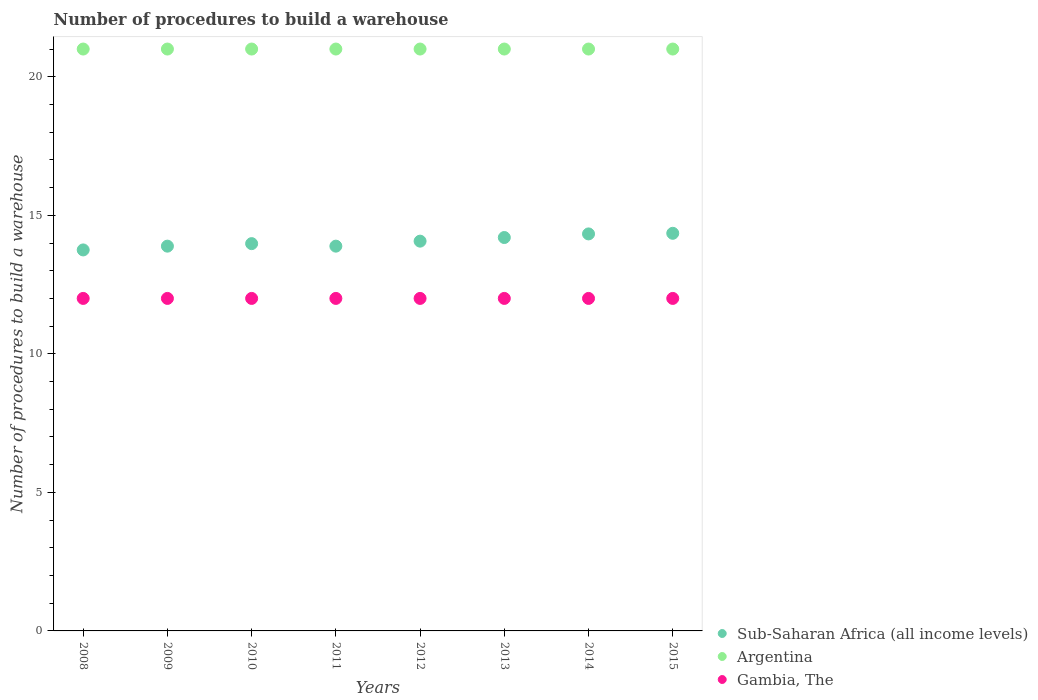How many different coloured dotlines are there?
Give a very brief answer. 3. Is the number of dotlines equal to the number of legend labels?
Make the answer very short. Yes. What is the number of procedures to build a warehouse in in Sub-Saharan Africa (all income levels) in 2011?
Offer a very short reply. 13.89. Across all years, what is the maximum number of procedures to build a warehouse in in Argentina?
Provide a succinct answer. 21. Across all years, what is the minimum number of procedures to build a warehouse in in Gambia, The?
Ensure brevity in your answer.  12. In which year was the number of procedures to build a warehouse in in Gambia, The maximum?
Your answer should be compact. 2008. In which year was the number of procedures to build a warehouse in in Gambia, The minimum?
Offer a terse response. 2008. What is the total number of procedures to build a warehouse in in Gambia, The in the graph?
Your answer should be very brief. 96. What is the difference between the number of procedures to build a warehouse in in Argentina in 2013 and that in 2015?
Give a very brief answer. 0. What is the difference between the number of procedures to build a warehouse in in Sub-Saharan Africa (all income levels) in 2012 and the number of procedures to build a warehouse in in Argentina in 2009?
Offer a very short reply. -6.93. What is the average number of procedures to build a warehouse in in Sub-Saharan Africa (all income levels) per year?
Offer a very short reply. 14.06. In the year 2013, what is the difference between the number of procedures to build a warehouse in in Gambia, The and number of procedures to build a warehouse in in Argentina?
Your answer should be compact. -9. In how many years, is the number of procedures to build a warehouse in in Argentina greater than 10?
Provide a short and direct response. 8. What is the ratio of the number of procedures to build a warehouse in in Gambia, The in 2011 to that in 2015?
Your answer should be very brief. 1. Is the number of procedures to build a warehouse in in Argentina in 2008 less than that in 2013?
Offer a very short reply. No. What is the difference between the highest and the second highest number of procedures to build a warehouse in in Sub-Saharan Africa (all income levels)?
Offer a very short reply. 0.02. What is the difference between the highest and the lowest number of procedures to build a warehouse in in Sub-Saharan Africa (all income levels)?
Ensure brevity in your answer.  0.6. Is the sum of the number of procedures to build a warehouse in in Argentina in 2011 and 2012 greater than the maximum number of procedures to build a warehouse in in Sub-Saharan Africa (all income levels) across all years?
Your answer should be compact. Yes. Is it the case that in every year, the sum of the number of procedures to build a warehouse in in Argentina and number of procedures to build a warehouse in in Sub-Saharan Africa (all income levels)  is greater than the number of procedures to build a warehouse in in Gambia, The?
Give a very brief answer. Yes. Is the number of procedures to build a warehouse in in Gambia, The strictly greater than the number of procedures to build a warehouse in in Sub-Saharan Africa (all income levels) over the years?
Ensure brevity in your answer.  No. Is the number of procedures to build a warehouse in in Argentina strictly less than the number of procedures to build a warehouse in in Gambia, The over the years?
Ensure brevity in your answer.  No. Are the values on the major ticks of Y-axis written in scientific E-notation?
Provide a short and direct response. No. Does the graph contain grids?
Your answer should be compact. No. Where does the legend appear in the graph?
Your answer should be very brief. Bottom right. How many legend labels are there?
Your response must be concise. 3. How are the legend labels stacked?
Make the answer very short. Vertical. What is the title of the graph?
Give a very brief answer. Number of procedures to build a warehouse. What is the label or title of the X-axis?
Make the answer very short. Years. What is the label or title of the Y-axis?
Provide a short and direct response. Number of procedures to build a warehouse. What is the Number of procedures to build a warehouse of Sub-Saharan Africa (all income levels) in 2008?
Give a very brief answer. 13.75. What is the Number of procedures to build a warehouse in Argentina in 2008?
Your answer should be very brief. 21. What is the Number of procedures to build a warehouse of Gambia, The in 2008?
Your response must be concise. 12. What is the Number of procedures to build a warehouse of Sub-Saharan Africa (all income levels) in 2009?
Provide a short and direct response. 13.89. What is the Number of procedures to build a warehouse in Gambia, The in 2009?
Your answer should be very brief. 12. What is the Number of procedures to build a warehouse in Sub-Saharan Africa (all income levels) in 2010?
Offer a very short reply. 13.98. What is the Number of procedures to build a warehouse of Argentina in 2010?
Ensure brevity in your answer.  21. What is the Number of procedures to build a warehouse of Sub-Saharan Africa (all income levels) in 2011?
Your answer should be very brief. 13.89. What is the Number of procedures to build a warehouse of Argentina in 2011?
Provide a short and direct response. 21. What is the Number of procedures to build a warehouse of Gambia, The in 2011?
Offer a terse response. 12. What is the Number of procedures to build a warehouse in Sub-Saharan Africa (all income levels) in 2012?
Your answer should be compact. 14.07. What is the Number of procedures to build a warehouse in Sub-Saharan Africa (all income levels) in 2013?
Offer a terse response. 14.2. What is the Number of procedures to build a warehouse of Sub-Saharan Africa (all income levels) in 2014?
Ensure brevity in your answer.  14.33. What is the Number of procedures to build a warehouse of Sub-Saharan Africa (all income levels) in 2015?
Your response must be concise. 14.35. Across all years, what is the maximum Number of procedures to build a warehouse in Sub-Saharan Africa (all income levels)?
Offer a terse response. 14.35. Across all years, what is the maximum Number of procedures to build a warehouse of Argentina?
Give a very brief answer. 21. Across all years, what is the minimum Number of procedures to build a warehouse in Sub-Saharan Africa (all income levels)?
Ensure brevity in your answer.  13.75. What is the total Number of procedures to build a warehouse of Sub-Saharan Africa (all income levels) in the graph?
Your response must be concise. 112.44. What is the total Number of procedures to build a warehouse in Argentina in the graph?
Your answer should be very brief. 168. What is the total Number of procedures to build a warehouse in Gambia, The in the graph?
Your answer should be very brief. 96. What is the difference between the Number of procedures to build a warehouse of Sub-Saharan Africa (all income levels) in 2008 and that in 2009?
Your response must be concise. -0.14. What is the difference between the Number of procedures to build a warehouse in Argentina in 2008 and that in 2009?
Give a very brief answer. 0. What is the difference between the Number of procedures to build a warehouse of Sub-Saharan Africa (all income levels) in 2008 and that in 2010?
Make the answer very short. -0.23. What is the difference between the Number of procedures to build a warehouse of Argentina in 2008 and that in 2010?
Ensure brevity in your answer.  0. What is the difference between the Number of procedures to build a warehouse of Gambia, The in 2008 and that in 2010?
Keep it short and to the point. 0. What is the difference between the Number of procedures to build a warehouse in Sub-Saharan Africa (all income levels) in 2008 and that in 2011?
Your answer should be compact. -0.14. What is the difference between the Number of procedures to build a warehouse of Sub-Saharan Africa (all income levels) in 2008 and that in 2012?
Provide a short and direct response. -0.32. What is the difference between the Number of procedures to build a warehouse of Argentina in 2008 and that in 2012?
Ensure brevity in your answer.  0. What is the difference between the Number of procedures to build a warehouse in Sub-Saharan Africa (all income levels) in 2008 and that in 2013?
Your answer should be compact. -0.45. What is the difference between the Number of procedures to build a warehouse in Argentina in 2008 and that in 2013?
Provide a short and direct response. 0. What is the difference between the Number of procedures to build a warehouse in Gambia, The in 2008 and that in 2013?
Your response must be concise. 0. What is the difference between the Number of procedures to build a warehouse in Sub-Saharan Africa (all income levels) in 2008 and that in 2014?
Your answer should be very brief. -0.58. What is the difference between the Number of procedures to build a warehouse of Sub-Saharan Africa (all income levels) in 2009 and that in 2010?
Your answer should be compact. -0.09. What is the difference between the Number of procedures to build a warehouse in Argentina in 2009 and that in 2010?
Give a very brief answer. 0. What is the difference between the Number of procedures to build a warehouse in Sub-Saharan Africa (all income levels) in 2009 and that in 2012?
Give a very brief answer. -0.18. What is the difference between the Number of procedures to build a warehouse in Gambia, The in 2009 and that in 2012?
Make the answer very short. 0. What is the difference between the Number of procedures to build a warehouse in Sub-Saharan Africa (all income levels) in 2009 and that in 2013?
Your response must be concise. -0.31. What is the difference between the Number of procedures to build a warehouse in Gambia, The in 2009 and that in 2013?
Give a very brief answer. 0. What is the difference between the Number of procedures to build a warehouse of Sub-Saharan Africa (all income levels) in 2009 and that in 2014?
Keep it short and to the point. -0.44. What is the difference between the Number of procedures to build a warehouse of Argentina in 2009 and that in 2014?
Keep it short and to the point. 0. What is the difference between the Number of procedures to build a warehouse of Sub-Saharan Africa (all income levels) in 2009 and that in 2015?
Ensure brevity in your answer.  -0.46. What is the difference between the Number of procedures to build a warehouse of Sub-Saharan Africa (all income levels) in 2010 and that in 2011?
Your response must be concise. 0.09. What is the difference between the Number of procedures to build a warehouse in Gambia, The in 2010 and that in 2011?
Your answer should be compact. 0. What is the difference between the Number of procedures to build a warehouse of Sub-Saharan Africa (all income levels) in 2010 and that in 2012?
Offer a very short reply. -0.09. What is the difference between the Number of procedures to build a warehouse of Argentina in 2010 and that in 2012?
Your response must be concise. 0. What is the difference between the Number of procedures to build a warehouse in Gambia, The in 2010 and that in 2012?
Offer a very short reply. 0. What is the difference between the Number of procedures to build a warehouse of Sub-Saharan Africa (all income levels) in 2010 and that in 2013?
Make the answer very short. -0.22. What is the difference between the Number of procedures to build a warehouse in Argentina in 2010 and that in 2013?
Ensure brevity in your answer.  0. What is the difference between the Number of procedures to build a warehouse in Sub-Saharan Africa (all income levels) in 2010 and that in 2014?
Your response must be concise. -0.35. What is the difference between the Number of procedures to build a warehouse in Argentina in 2010 and that in 2014?
Offer a very short reply. 0. What is the difference between the Number of procedures to build a warehouse of Gambia, The in 2010 and that in 2014?
Provide a short and direct response. 0. What is the difference between the Number of procedures to build a warehouse of Sub-Saharan Africa (all income levels) in 2010 and that in 2015?
Give a very brief answer. -0.37. What is the difference between the Number of procedures to build a warehouse of Gambia, The in 2010 and that in 2015?
Your answer should be compact. 0. What is the difference between the Number of procedures to build a warehouse in Sub-Saharan Africa (all income levels) in 2011 and that in 2012?
Give a very brief answer. -0.18. What is the difference between the Number of procedures to build a warehouse in Sub-Saharan Africa (all income levels) in 2011 and that in 2013?
Provide a succinct answer. -0.31. What is the difference between the Number of procedures to build a warehouse in Argentina in 2011 and that in 2013?
Ensure brevity in your answer.  0. What is the difference between the Number of procedures to build a warehouse of Sub-Saharan Africa (all income levels) in 2011 and that in 2014?
Provide a succinct answer. -0.44. What is the difference between the Number of procedures to build a warehouse of Sub-Saharan Africa (all income levels) in 2011 and that in 2015?
Provide a short and direct response. -0.46. What is the difference between the Number of procedures to build a warehouse of Argentina in 2011 and that in 2015?
Provide a short and direct response. 0. What is the difference between the Number of procedures to build a warehouse of Gambia, The in 2011 and that in 2015?
Ensure brevity in your answer.  0. What is the difference between the Number of procedures to build a warehouse of Sub-Saharan Africa (all income levels) in 2012 and that in 2013?
Provide a short and direct response. -0.13. What is the difference between the Number of procedures to build a warehouse in Argentina in 2012 and that in 2013?
Provide a succinct answer. 0. What is the difference between the Number of procedures to build a warehouse in Gambia, The in 2012 and that in 2013?
Your response must be concise. 0. What is the difference between the Number of procedures to build a warehouse in Sub-Saharan Africa (all income levels) in 2012 and that in 2014?
Provide a succinct answer. -0.26. What is the difference between the Number of procedures to build a warehouse in Gambia, The in 2012 and that in 2014?
Give a very brief answer. 0. What is the difference between the Number of procedures to build a warehouse in Sub-Saharan Africa (all income levels) in 2012 and that in 2015?
Your response must be concise. -0.28. What is the difference between the Number of procedures to build a warehouse in Gambia, The in 2012 and that in 2015?
Ensure brevity in your answer.  0. What is the difference between the Number of procedures to build a warehouse in Sub-Saharan Africa (all income levels) in 2013 and that in 2014?
Keep it short and to the point. -0.13. What is the difference between the Number of procedures to build a warehouse of Argentina in 2013 and that in 2014?
Provide a short and direct response. 0. What is the difference between the Number of procedures to build a warehouse of Gambia, The in 2013 and that in 2014?
Provide a succinct answer. 0. What is the difference between the Number of procedures to build a warehouse in Sub-Saharan Africa (all income levels) in 2013 and that in 2015?
Provide a succinct answer. -0.15. What is the difference between the Number of procedures to build a warehouse in Sub-Saharan Africa (all income levels) in 2014 and that in 2015?
Give a very brief answer. -0.02. What is the difference between the Number of procedures to build a warehouse of Argentina in 2014 and that in 2015?
Offer a terse response. 0. What is the difference between the Number of procedures to build a warehouse in Sub-Saharan Africa (all income levels) in 2008 and the Number of procedures to build a warehouse in Argentina in 2009?
Your answer should be compact. -7.25. What is the difference between the Number of procedures to build a warehouse in Sub-Saharan Africa (all income levels) in 2008 and the Number of procedures to build a warehouse in Gambia, The in 2009?
Your answer should be very brief. 1.75. What is the difference between the Number of procedures to build a warehouse in Sub-Saharan Africa (all income levels) in 2008 and the Number of procedures to build a warehouse in Argentina in 2010?
Provide a short and direct response. -7.25. What is the difference between the Number of procedures to build a warehouse of Argentina in 2008 and the Number of procedures to build a warehouse of Gambia, The in 2010?
Give a very brief answer. 9. What is the difference between the Number of procedures to build a warehouse of Sub-Saharan Africa (all income levels) in 2008 and the Number of procedures to build a warehouse of Argentina in 2011?
Provide a short and direct response. -7.25. What is the difference between the Number of procedures to build a warehouse in Sub-Saharan Africa (all income levels) in 2008 and the Number of procedures to build a warehouse in Gambia, The in 2011?
Offer a terse response. 1.75. What is the difference between the Number of procedures to build a warehouse of Argentina in 2008 and the Number of procedures to build a warehouse of Gambia, The in 2011?
Ensure brevity in your answer.  9. What is the difference between the Number of procedures to build a warehouse in Sub-Saharan Africa (all income levels) in 2008 and the Number of procedures to build a warehouse in Argentina in 2012?
Give a very brief answer. -7.25. What is the difference between the Number of procedures to build a warehouse of Sub-Saharan Africa (all income levels) in 2008 and the Number of procedures to build a warehouse of Argentina in 2013?
Give a very brief answer. -7.25. What is the difference between the Number of procedures to build a warehouse of Sub-Saharan Africa (all income levels) in 2008 and the Number of procedures to build a warehouse of Gambia, The in 2013?
Your answer should be very brief. 1.75. What is the difference between the Number of procedures to build a warehouse in Sub-Saharan Africa (all income levels) in 2008 and the Number of procedures to build a warehouse in Argentina in 2014?
Your answer should be compact. -7.25. What is the difference between the Number of procedures to build a warehouse of Sub-Saharan Africa (all income levels) in 2008 and the Number of procedures to build a warehouse of Gambia, The in 2014?
Your answer should be compact. 1.75. What is the difference between the Number of procedures to build a warehouse in Sub-Saharan Africa (all income levels) in 2008 and the Number of procedures to build a warehouse in Argentina in 2015?
Give a very brief answer. -7.25. What is the difference between the Number of procedures to build a warehouse in Sub-Saharan Africa (all income levels) in 2008 and the Number of procedures to build a warehouse in Gambia, The in 2015?
Offer a terse response. 1.75. What is the difference between the Number of procedures to build a warehouse of Argentina in 2008 and the Number of procedures to build a warehouse of Gambia, The in 2015?
Offer a very short reply. 9. What is the difference between the Number of procedures to build a warehouse in Sub-Saharan Africa (all income levels) in 2009 and the Number of procedures to build a warehouse in Argentina in 2010?
Provide a succinct answer. -7.11. What is the difference between the Number of procedures to build a warehouse in Sub-Saharan Africa (all income levels) in 2009 and the Number of procedures to build a warehouse in Gambia, The in 2010?
Ensure brevity in your answer.  1.89. What is the difference between the Number of procedures to build a warehouse in Argentina in 2009 and the Number of procedures to build a warehouse in Gambia, The in 2010?
Offer a terse response. 9. What is the difference between the Number of procedures to build a warehouse of Sub-Saharan Africa (all income levels) in 2009 and the Number of procedures to build a warehouse of Argentina in 2011?
Make the answer very short. -7.11. What is the difference between the Number of procedures to build a warehouse of Sub-Saharan Africa (all income levels) in 2009 and the Number of procedures to build a warehouse of Gambia, The in 2011?
Provide a succinct answer. 1.89. What is the difference between the Number of procedures to build a warehouse of Sub-Saharan Africa (all income levels) in 2009 and the Number of procedures to build a warehouse of Argentina in 2012?
Offer a very short reply. -7.11. What is the difference between the Number of procedures to build a warehouse of Sub-Saharan Africa (all income levels) in 2009 and the Number of procedures to build a warehouse of Gambia, The in 2012?
Give a very brief answer. 1.89. What is the difference between the Number of procedures to build a warehouse in Argentina in 2009 and the Number of procedures to build a warehouse in Gambia, The in 2012?
Provide a succinct answer. 9. What is the difference between the Number of procedures to build a warehouse of Sub-Saharan Africa (all income levels) in 2009 and the Number of procedures to build a warehouse of Argentina in 2013?
Keep it short and to the point. -7.11. What is the difference between the Number of procedures to build a warehouse of Sub-Saharan Africa (all income levels) in 2009 and the Number of procedures to build a warehouse of Gambia, The in 2013?
Provide a short and direct response. 1.89. What is the difference between the Number of procedures to build a warehouse of Sub-Saharan Africa (all income levels) in 2009 and the Number of procedures to build a warehouse of Argentina in 2014?
Ensure brevity in your answer.  -7.11. What is the difference between the Number of procedures to build a warehouse of Sub-Saharan Africa (all income levels) in 2009 and the Number of procedures to build a warehouse of Gambia, The in 2014?
Provide a short and direct response. 1.89. What is the difference between the Number of procedures to build a warehouse in Argentina in 2009 and the Number of procedures to build a warehouse in Gambia, The in 2014?
Give a very brief answer. 9. What is the difference between the Number of procedures to build a warehouse of Sub-Saharan Africa (all income levels) in 2009 and the Number of procedures to build a warehouse of Argentina in 2015?
Your response must be concise. -7.11. What is the difference between the Number of procedures to build a warehouse of Sub-Saharan Africa (all income levels) in 2009 and the Number of procedures to build a warehouse of Gambia, The in 2015?
Provide a short and direct response. 1.89. What is the difference between the Number of procedures to build a warehouse of Sub-Saharan Africa (all income levels) in 2010 and the Number of procedures to build a warehouse of Argentina in 2011?
Give a very brief answer. -7.02. What is the difference between the Number of procedures to build a warehouse of Sub-Saharan Africa (all income levels) in 2010 and the Number of procedures to build a warehouse of Gambia, The in 2011?
Your answer should be compact. 1.98. What is the difference between the Number of procedures to build a warehouse of Argentina in 2010 and the Number of procedures to build a warehouse of Gambia, The in 2011?
Give a very brief answer. 9. What is the difference between the Number of procedures to build a warehouse of Sub-Saharan Africa (all income levels) in 2010 and the Number of procedures to build a warehouse of Argentina in 2012?
Offer a very short reply. -7.02. What is the difference between the Number of procedures to build a warehouse of Sub-Saharan Africa (all income levels) in 2010 and the Number of procedures to build a warehouse of Gambia, The in 2012?
Provide a short and direct response. 1.98. What is the difference between the Number of procedures to build a warehouse of Sub-Saharan Africa (all income levels) in 2010 and the Number of procedures to build a warehouse of Argentina in 2013?
Make the answer very short. -7.02. What is the difference between the Number of procedures to build a warehouse of Sub-Saharan Africa (all income levels) in 2010 and the Number of procedures to build a warehouse of Gambia, The in 2013?
Offer a very short reply. 1.98. What is the difference between the Number of procedures to build a warehouse of Argentina in 2010 and the Number of procedures to build a warehouse of Gambia, The in 2013?
Offer a very short reply. 9. What is the difference between the Number of procedures to build a warehouse of Sub-Saharan Africa (all income levels) in 2010 and the Number of procedures to build a warehouse of Argentina in 2014?
Ensure brevity in your answer.  -7.02. What is the difference between the Number of procedures to build a warehouse of Sub-Saharan Africa (all income levels) in 2010 and the Number of procedures to build a warehouse of Gambia, The in 2014?
Make the answer very short. 1.98. What is the difference between the Number of procedures to build a warehouse of Sub-Saharan Africa (all income levels) in 2010 and the Number of procedures to build a warehouse of Argentina in 2015?
Make the answer very short. -7.02. What is the difference between the Number of procedures to build a warehouse of Sub-Saharan Africa (all income levels) in 2010 and the Number of procedures to build a warehouse of Gambia, The in 2015?
Your answer should be very brief. 1.98. What is the difference between the Number of procedures to build a warehouse in Sub-Saharan Africa (all income levels) in 2011 and the Number of procedures to build a warehouse in Argentina in 2012?
Your answer should be very brief. -7.11. What is the difference between the Number of procedures to build a warehouse of Sub-Saharan Africa (all income levels) in 2011 and the Number of procedures to build a warehouse of Gambia, The in 2012?
Your answer should be compact. 1.89. What is the difference between the Number of procedures to build a warehouse in Argentina in 2011 and the Number of procedures to build a warehouse in Gambia, The in 2012?
Your answer should be very brief. 9. What is the difference between the Number of procedures to build a warehouse in Sub-Saharan Africa (all income levels) in 2011 and the Number of procedures to build a warehouse in Argentina in 2013?
Make the answer very short. -7.11. What is the difference between the Number of procedures to build a warehouse in Sub-Saharan Africa (all income levels) in 2011 and the Number of procedures to build a warehouse in Gambia, The in 2013?
Keep it short and to the point. 1.89. What is the difference between the Number of procedures to build a warehouse of Sub-Saharan Africa (all income levels) in 2011 and the Number of procedures to build a warehouse of Argentina in 2014?
Offer a very short reply. -7.11. What is the difference between the Number of procedures to build a warehouse of Sub-Saharan Africa (all income levels) in 2011 and the Number of procedures to build a warehouse of Gambia, The in 2014?
Keep it short and to the point. 1.89. What is the difference between the Number of procedures to build a warehouse in Sub-Saharan Africa (all income levels) in 2011 and the Number of procedures to build a warehouse in Argentina in 2015?
Give a very brief answer. -7.11. What is the difference between the Number of procedures to build a warehouse of Sub-Saharan Africa (all income levels) in 2011 and the Number of procedures to build a warehouse of Gambia, The in 2015?
Make the answer very short. 1.89. What is the difference between the Number of procedures to build a warehouse of Sub-Saharan Africa (all income levels) in 2012 and the Number of procedures to build a warehouse of Argentina in 2013?
Ensure brevity in your answer.  -6.93. What is the difference between the Number of procedures to build a warehouse of Sub-Saharan Africa (all income levels) in 2012 and the Number of procedures to build a warehouse of Gambia, The in 2013?
Your response must be concise. 2.07. What is the difference between the Number of procedures to build a warehouse in Argentina in 2012 and the Number of procedures to build a warehouse in Gambia, The in 2013?
Offer a terse response. 9. What is the difference between the Number of procedures to build a warehouse of Sub-Saharan Africa (all income levels) in 2012 and the Number of procedures to build a warehouse of Argentina in 2014?
Offer a very short reply. -6.93. What is the difference between the Number of procedures to build a warehouse in Sub-Saharan Africa (all income levels) in 2012 and the Number of procedures to build a warehouse in Gambia, The in 2014?
Make the answer very short. 2.07. What is the difference between the Number of procedures to build a warehouse in Argentina in 2012 and the Number of procedures to build a warehouse in Gambia, The in 2014?
Your answer should be compact. 9. What is the difference between the Number of procedures to build a warehouse of Sub-Saharan Africa (all income levels) in 2012 and the Number of procedures to build a warehouse of Argentina in 2015?
Ensure brevity in your answer.  -6.93. What is the difference between the Number of procedures to build a warehouse of Sub-Saharan Africa (all income levels) in 2012 and the Number of procedures to build a warehouse of Gambia, The in 2015?
Give a very brief answer. 2.07. What is the difference between the Number of procedures to build a warehouse of Sub-Saharan Africa (all income levels) in 2013 and the Number of procedures to build a warehouse of Argentina in 2014?
Offer a terse response. -6.8. What is the difference between the Number of procedures to build a warehouse of Sub-Saharan Africa (all income levels) in 2013 and the Number of procedures to build a warehouse of Gambia, The in 2014?
Offer a terse response. 2.2. What is the difference between the Number of procedures to build a warehouse in Argentina in 2013 and the Number of procedures to build a warehouse in Gambia, The in 2014?
Keep it short and to the point. 9. What is the difference between the Number of procedures to build a warehouse of Sub-Saharan Africa (all income levels) in 2013 and the Number of procedures to build a warehouse of Argentina in 2015?
Ensure brevity in your answer.  -6.8. What is the difference between the Number of procedures to build a warehouse of Sub-Saharan Africa (all income levels) in 2013 and the Number of procedures to build a warehouse of Gambia, The in 2015?
Provide a succinct answer. 2.2. What is the difference between the Number of procedures to build a warehouse of Argentina in 2013 and the Number of procedures to build a warehouse of Gambia, The in 2015?
Give a very brief answer. 9. What is the difference between the Number of procedures to build a warehouse of Sub-Saharan Africa (all income levels) in 2014 and the Number of procedures to build a warehouse of Argentina in 2015?
Ensure brevity in your answer.  -6.67. What is the difference between the Number of procedures to build a warehouse in Sub-Saharan Africa (all income levels) in 2014 and the Number of procedures to build a warehouse in Gambia, The in 2015?
Your response must be concise. 2.33. What is the difference between the Number of procedures to build a warehouse of Argentina in 2014 and the Number of procedures to build a warehouse of Gambia, The in 2015?
Offer a very short reply. 9. What is the average Number of procedures to build a warehouse of Sub-Saharan Africa (all income levels) per year?
Your answer should be compact. 14.06. What is the average Number of procedures to build a warehouse in Argentina per year?
Give a very brief answer. 21. What is the average Number of procedures to build a warehouse in Gambia, The per year?
Provide a succinct answer. 12. In the year 2008, what is the difference between the Number of procedures to build a warehouse in Sub-Saharan Africa (all income levels) and Number of procedures to build a warehouse in Argentina?
Keep it short and to the point. -7.25. In the year 2009, what is the difference between the Number of procedures to build a warehouse of Sub-Saharan Africa (all income levels) and Number of procedures to build a warehouse of Argentina?
Make the answer very short. -7.11. In the year 2009, what is the difference between the Number of procedures to build a warehouse in Sub-Saharan Africa (all income levels) and Number of procedures to build a warehouse in Gambia, The?
Keep it short and to the point. 1.89. In the year 2009, what is the difference between the Number of procedures to build a warehouse in Argentina and Number of procedures to build a warehouse in Gambia, The?
Provide a short and direct response. 9. In the year 2010, what is the difference between the Number of procedures to build a warehouse of Sub-Saharan Africa (all income levels) and Number of procedures to build a warehouse of Argentina?
Your answer should be very brief. -7.02. In the year 2010, what is the difference between the Number of procedures to build a warehouse of Sub-Saharan Africa (all income levels) and Number of procedures to build a warehouse of Gambia, The?
Your answer should be compact. 1.98. In the year 2010, what is the difference between the Number of procedures to build a warehouse of Argentina and Number of procedures to build a warehouse of Gambia, The?
Offer a terse response. 9. In the year 2011, what is the difference between the Number of procedures to build a warehouse in Sub-Saharan Africa (all income levels) and Number of procedures to build a warehouse in Argentina?
Make the answer very short. -7.11. In the year 2011, what is the difference between the Number of procedures to build a warehouse of Sub-Saharan Africa (all income levels) and Number of procedures to build a warehouse of Gambia, The?
Your answer should be compact. 1.89. In the year 2011, what is the difference between the Number of procedures to build a warehouse of Argentina and Number of procedures to build a warehouse of Gambia, The?
Provide a succinct answer. 9. In the year 2012, what is the difference between the Number of procedures to build a warehouse in Sub-Saharan Africa (all income levels) and Number of procedures to build a warehouse in Argentina?
Your answer should be very brief. -6.93. In the year 2012, what is the difference between the Number of procedures to build a warehouse of Sub-Saharan Africa (all income levels) and Number of procedures to build a warehouse of Gambia, The?
Your answer should be compact. 2.07. In the year 2013, what is the difference between the Number of procedures to build a warehouse of Sub-Saharan Africa (all income levels) and Number of procedures to build a warehouse of Argentina?
Your answer should be compact. -6.8. In the year 2013, what is the difference between the Number of procedures to build a warehouse of Sub-Saharan Africa (all income levels) and Number of procedures to build a warehouse of Gambia, The?
Your response must be concise. 2.2. In the year 2014, what is the difference between the Number of procedures to build a warehouse in Sub-Saharan Africa (all income levels) and Number of procedures to build a warehouse in Argentina?
Offer a very short reply. -6.67. In the year 2014, what is the difference between the Number of procedures to build a warehouse of Sub-Saharan Africa (all income levels) and Number of procedures to build a warehouse of Gambia, The?
Provide a short and direct response. 2.33. In the year 2014, what is the difference between the Number of procedures to build a warehouse of Argentina and Number of procedures to build a warehouse of Gambia, The?
Provide a succinct answer. 9. In the year 2015, what is the difference between the Number of procedures to build a warehouse in Sub-Saharan Africa (all income levels) and Number of procedures to build a warehouse in Argentina?
Your response must be concise. -6.65. In the year 2015, what is the difference between the Number of procedures to build a warehouse in Sub-Saharan Africa (all income levels) and Number of procedures to build a warehouse in Gambia, The?
Provide a short and direct response. 2.35. In the year 2015, what is the difference between the Number of procedures to build a warehouse in Argentina and Number of procedures to build a warehouse in Gambia, The?
Give a very brief answer. 9. What is the ratio of the Number of procedures to build a warehouse of Sub-Saharan Africa (all income levels) in 2008 to that in 2009?
Your response must be concise. 0.99. What is the ratio of the Number of procedures to build a warehouse in Gambia, The in 2008 to that in 2009?
Ensure brevity in your answer.  1. What is the ratio of the Number of procedures to build a warehouse of Sub-Saharan Africa (all income levels) in 2008 to that in 2010?
Your response must be concise. 0.98. What is the ratio of the Number of procedures to build a warehouse in Sub-Saharan Africa (all income levels) in 2008 to that in 2011?
Give a very brief answer. 0.99. What is the ratio of the Number of procedures to build a warehouse of Gambia, The in 2008 to that in 2011?
Your answer should be very brief. 1. What is the ratio of the Number of procedures to build a warehouse of Sub-Saharan Africa (all income levels) in 2008 to that in 2012?
Offer a very short reply. 0.98. What is the ratio of the Number of procedures to build a warehouse of Argentina in 2008 to that in 2012?
Make the answer very short. 1. What is the ratio of the Number of procedures to build a warehouse of Sub-Saharan Africa (all income levels) in 2008 to that in 2013?
Offer a very short reply. 0.97. What is the ratio of the Number of procedures to build a warehouse of Argentina in 2008 to that in 2013?
Keep it short and to the point. 1. What is the ratio of the Number of procedures to build a warehouse of Sub-Saharan Africa (all income levels) in 2008 to that in 2014?
Give a very brief answer. 0.96. What is the ratio of the Number of procedures to build a warehouse in Argentina in 2008 to that in 2014?
Ensure brevity in your answer.  1. What is the ratio of the Number of procedures to build a warehouse in Gambia, The in 2008 to that in 2014?
Offer a terse response. 1. What is the ratio of the Number of procedures to build a warehouse of Sub-Saharan Africa (all income levels) in 2008 to that in 2015?
Ensure brevity in your answer.  0.96. What is the ratio of the Number of procedures to build a warehouse of Argentina in 2008 to that in 2015?
Your response must be concise. 1. What is the ratio of the Number of procedures to build a warehouse of Gambia, The in 2008 to that in 2015?
Your response must be concise. 1. What is the ratio of the Number of procedures to build a warehouse in Argentina in 2009 to that in 2010?
Offer a terse response. 1. What is the ratio of the Number of procedures to build a warehouse in Gambia, The in 2009 to that in 2010?
Ensure brevity in your answer.  1. What is the ratio of the Number of procedures to build a warehouse in Sub-Saharan Africa (all income levels) in 2009 to that in 2011?
Offer a terse response. 1. What is the ratio of the Number of procedures to build a warehouse in Sub-Saharan Africa (all income levels) in 2009 to that in 2012?
Provide a short and direct response. 0.99. What is the ratio of the Number of procedures to build a warehouse in Sub-Saharan Africa (all income levels) in 2009 to that in 2013?
Provide a short and direct response. 0.98. What is the ratio of the Number of procedures to build a warehouse of Gambia, The in 2009 to that in 2013?
Offer a terse response. 1. What is the ratio of the Number of procedures to build a warehouse of Sub-Saharan Africa (all income levels) in 2009 to that in 2014?
Make the answer very short. 0.97. What is the ratio of the Number of procedures to build a warehouse in Gambia, The in 2009 to that in 2014?
Give a very brief answer. 1. What is the ratio of the Number of procedures to build a warehouse of Argentina in 2010 to that in 2011?
Your answer should be very brief. 1. What is the ratio of the Number of procedures to build a warehouse in Argentina in 2010 to that in 2012?
Provide a short and direct response. 1. What is the ratio of the Number of procedures to build a warehouse of Gambia, The in 2010 to that in 2012?
Offer a terse response. 1. What is the ratio of the Number of procedures to build a warehouse of Sub-Saharan Africa (all income levels) in 2010 to that in 2013?
Make the answer very short. 0.98. What is the ratio of the Number of procedures to build a warehouse of Gambia, The in 2010 to that in 2013?
Your answer should be very brief. 1. What is the ratio of the Number of procedures to build a warehouse of Sub-Saharan Africa (all income levels) in 2010 to that in 2014?
Provide a short and direct response. 0.98. What is the ratio of the Number of procedures to build a warehouse in Argentina in 2010 to that in 2014?
Ensure brevity in your answer.  1. What is the ratio of the Number of procedures to build a warehouse of Sub-Saharan Africa (all income levels) in 2010 to that in 2015?
Your response must be concise. 0.97. What is the ratio of the Number of procedures to build a warehouse of Sub-Saharan Africa (all income levels) in 2011 to that in 2012?
Your answer should be very brief. 0.99. What is the ratio of the Number of procedures to build a warehouse in Argentina in 2011 to that in 2012?
Your answer should be very brief. 1. What is the ratio of the Number of procedures to build a warehouse in Sub-Saharan Africa (all income levels) in 2011 to that in 2013?
Give a very brief answer. 0.98. What is the ratio of the Number of procedures to build a warehouse in Argentina in 2011 to that in 2013?
Provide a succinct answer. 1. What is the ratio of the Number of procedures to build a warehouse of Sub-Saharan Africa (all income levels) in 2011 to that in 2014?
Give a very brief answer. 0.97. What is the ratio of the Number of procedures to build a warehouse of Argentina in 2011 to that in 2014?
Your answer should be compact. 1. What is the ratio of the Number of procedures to build a warehouse in Argentina in 2011 to that in 2015?
Ensure brevity in your answer.  1. What is the ratio of the Number of procedures to build a warehouse in Sub-Saharan Africa (all income levels) in 2012 to that in 2013?
Your answer should be very brief. 0.99. What is the ratio of the Number of procedures to build a warehouse of Sub-Saharan Africa (all income levels) in 2012 to that in 2014?
Ensure brevity in your answer.  0.98. What is the ratio of the Number of procedures to build a warehouse in Argentina in 2012 to that in 2014?
Give a very brief answer. 1. What is the ratio of the Number of procedures to build a warehouse in Gambia, The in 2012 to that in 2014?
Your answer should be very brief. 1. What is the ratio of the Number of procedures to build a warehouse in Sub-Saharan Africa (all income levels) in 2012 to that in 2015?
Your response must be concise. 0.98. What is the ratio of the Number of procedures to build a warehouse of Argentina in 2012 to that in 2015?
Ensure brevity in your answer.  1. What is the ratio of the Number of procedures to build a warehouse in Sub-Saharan Africa (all income levels) in 2013 to that in 2014?
Provide a succinct answer. 0.99. What is the ratio of the Number of procedures to build a warehouse of Gambia, The in 2013 to that in 2014?
Provide a short and direct response. 1. What is the ratio of the Number of procedures to build a warehouse in Sub-Saharan Africa (all income levels) in 2013 to that in 2015?
Ensure brevity in your answer.  0.99. What is the ratio of the Number of procedures to build a warehouse of Argentina in 2013 to that in 2015?
Offer a very short reply. 1. What is the ratio of the Number of procedures to build a warehouse of Argentina in 2014 to that in 2015?
Make the answer very short. 1. What is the ratio of the Number of procedures to build a warehouse in Gambia, The in 2014 to that in 2015?
Give a very brief answer. 1. What is the difference between the highest and the second highest Number of procedures to build a warehouse in Sub-Saharan Africa (all income levels)?
Provide a succinct answer. 0.02. What is the difference between the highest and the second highest Number of procedures to build a warehouse of Argentina?
Ensure brevity in your answer.  0. What is the difference between the highest and the second highest Number of procedures to build a warehouse of Gambia, The?
Provide a short and direct response. 0. What is the difference between the highest and the lowest Number of procedures to build a warehouse in Argentina?
Provide a short and direct response. 0. What is the difference between the highest and the lowest Number of procedures to build a warehouse in Gambia, The?
Your answer should be very brief. 0. 